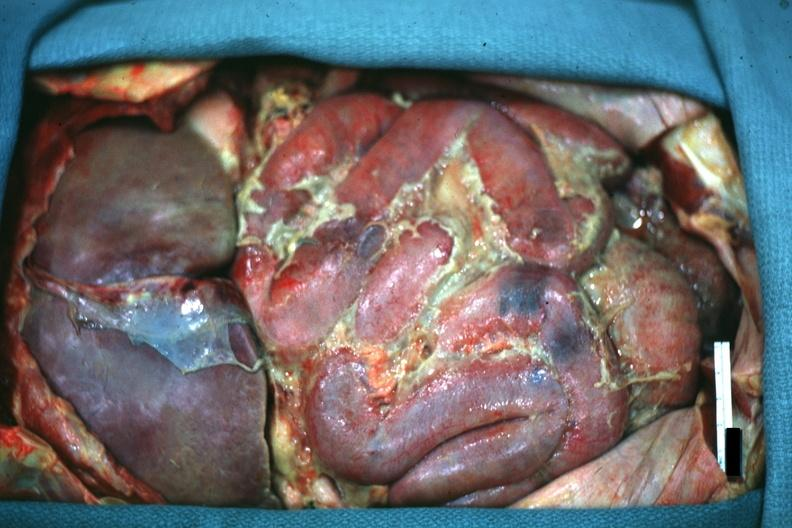s acute peritonitis present?
Answer the question using a single word or phrase. Yes 